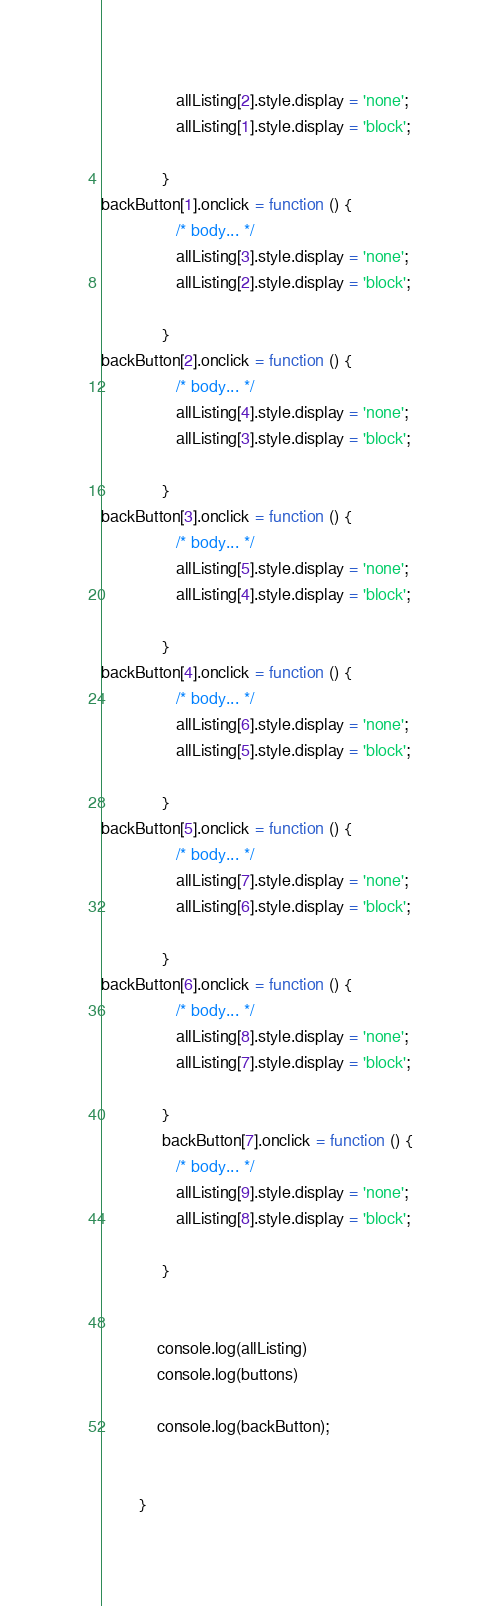Convert code to text. <code><loc_0><loc_0><loc_500><loc_500><_JavaScript_>			 	allListing[2].style.display = 'none';
	 			allListing[1].style.display = 'block';

			 }
backButton[1].onclick = function () {
			 	/* body... */
			 	allListing[3].style.display = 'none';
	 			allListing[2].style.display = 'block';

			 }
backButton[2].onclick = function () {
			 	/* body... */
			 	allListing[4].style.display = 'none';
	 			allListing[3].style.display = 'block';

			 }
backButton[3].onclick = function () {
			 	/* body... */
			 	allListing[5].style.display = 'none';
	 			allListing[4].style.display = 'block';

			 }
backButton[4].onclick = function () {
			 	/* body... */
			 	allListing[6].style.display = 'none';
	 			allListing[5].style.display = 'block';

			 }
backButton[5].onclick = function () {
			 	/* body... */
			 	allListing[7].style.display = 'none';
	 			allListing[6].style.display = 'block';

			 }
backButton[6].onclick = function () {
			 	/* body... */
			 	allListing[8].style.display = 'none';
	 			allListing[7].style.display = 'block';

			 }
			 backButton[7].onclick = function () {
			 	/* body... */
			 	allListing[9].style.display = 'none';
	 			allListing[8].style.display = 'block';

			 }
 

	 		console.log(allListing)
	 		console.log(buttons)
 	 		
	 		console.log(backButton);

 
	 	}</code> 